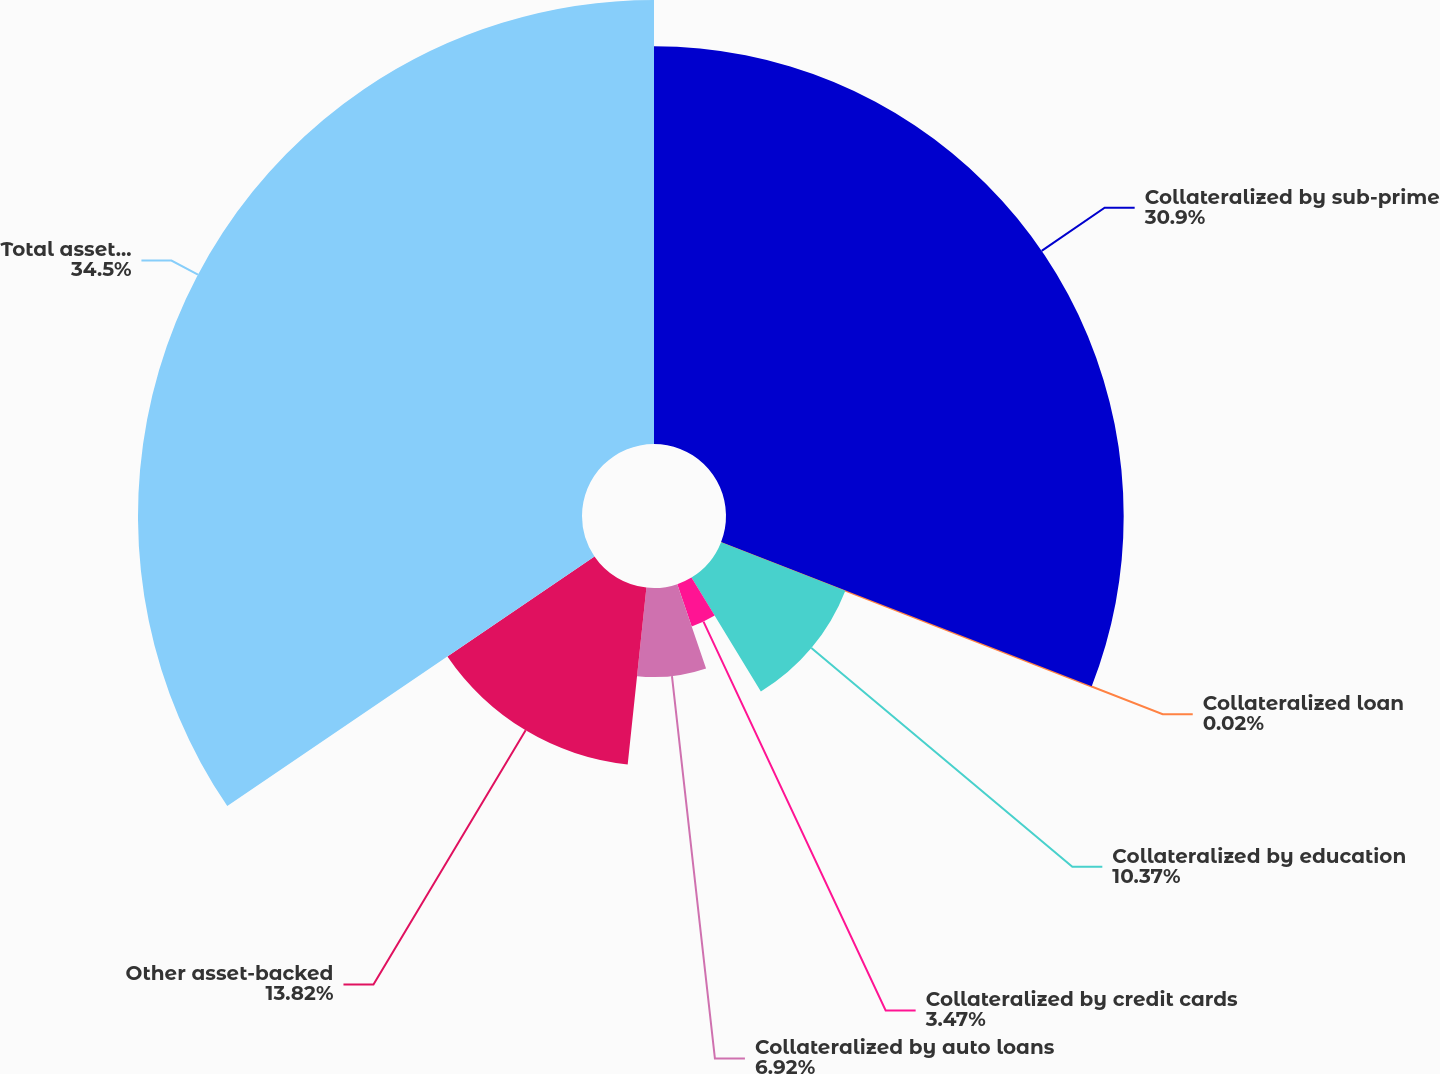<chart> <loc_0><loc_0><loc_500><loc_500><pie_chart><fcel>Collateralized by sub-prime<fcel>Collateralized loan<fcel>Collateralized by education<fcel>Collateralized by credit cards<fcel>Collateralized by auto loans<fcel>Other asset-backed<fcel>Total asset-backed<nl><fcel>30.91%<fcel>0.02%<fcel>10.37%<fcel>3.47%<fcel>6.92%<fcel>13.82%<fcel>34.51%<nl></chart> 